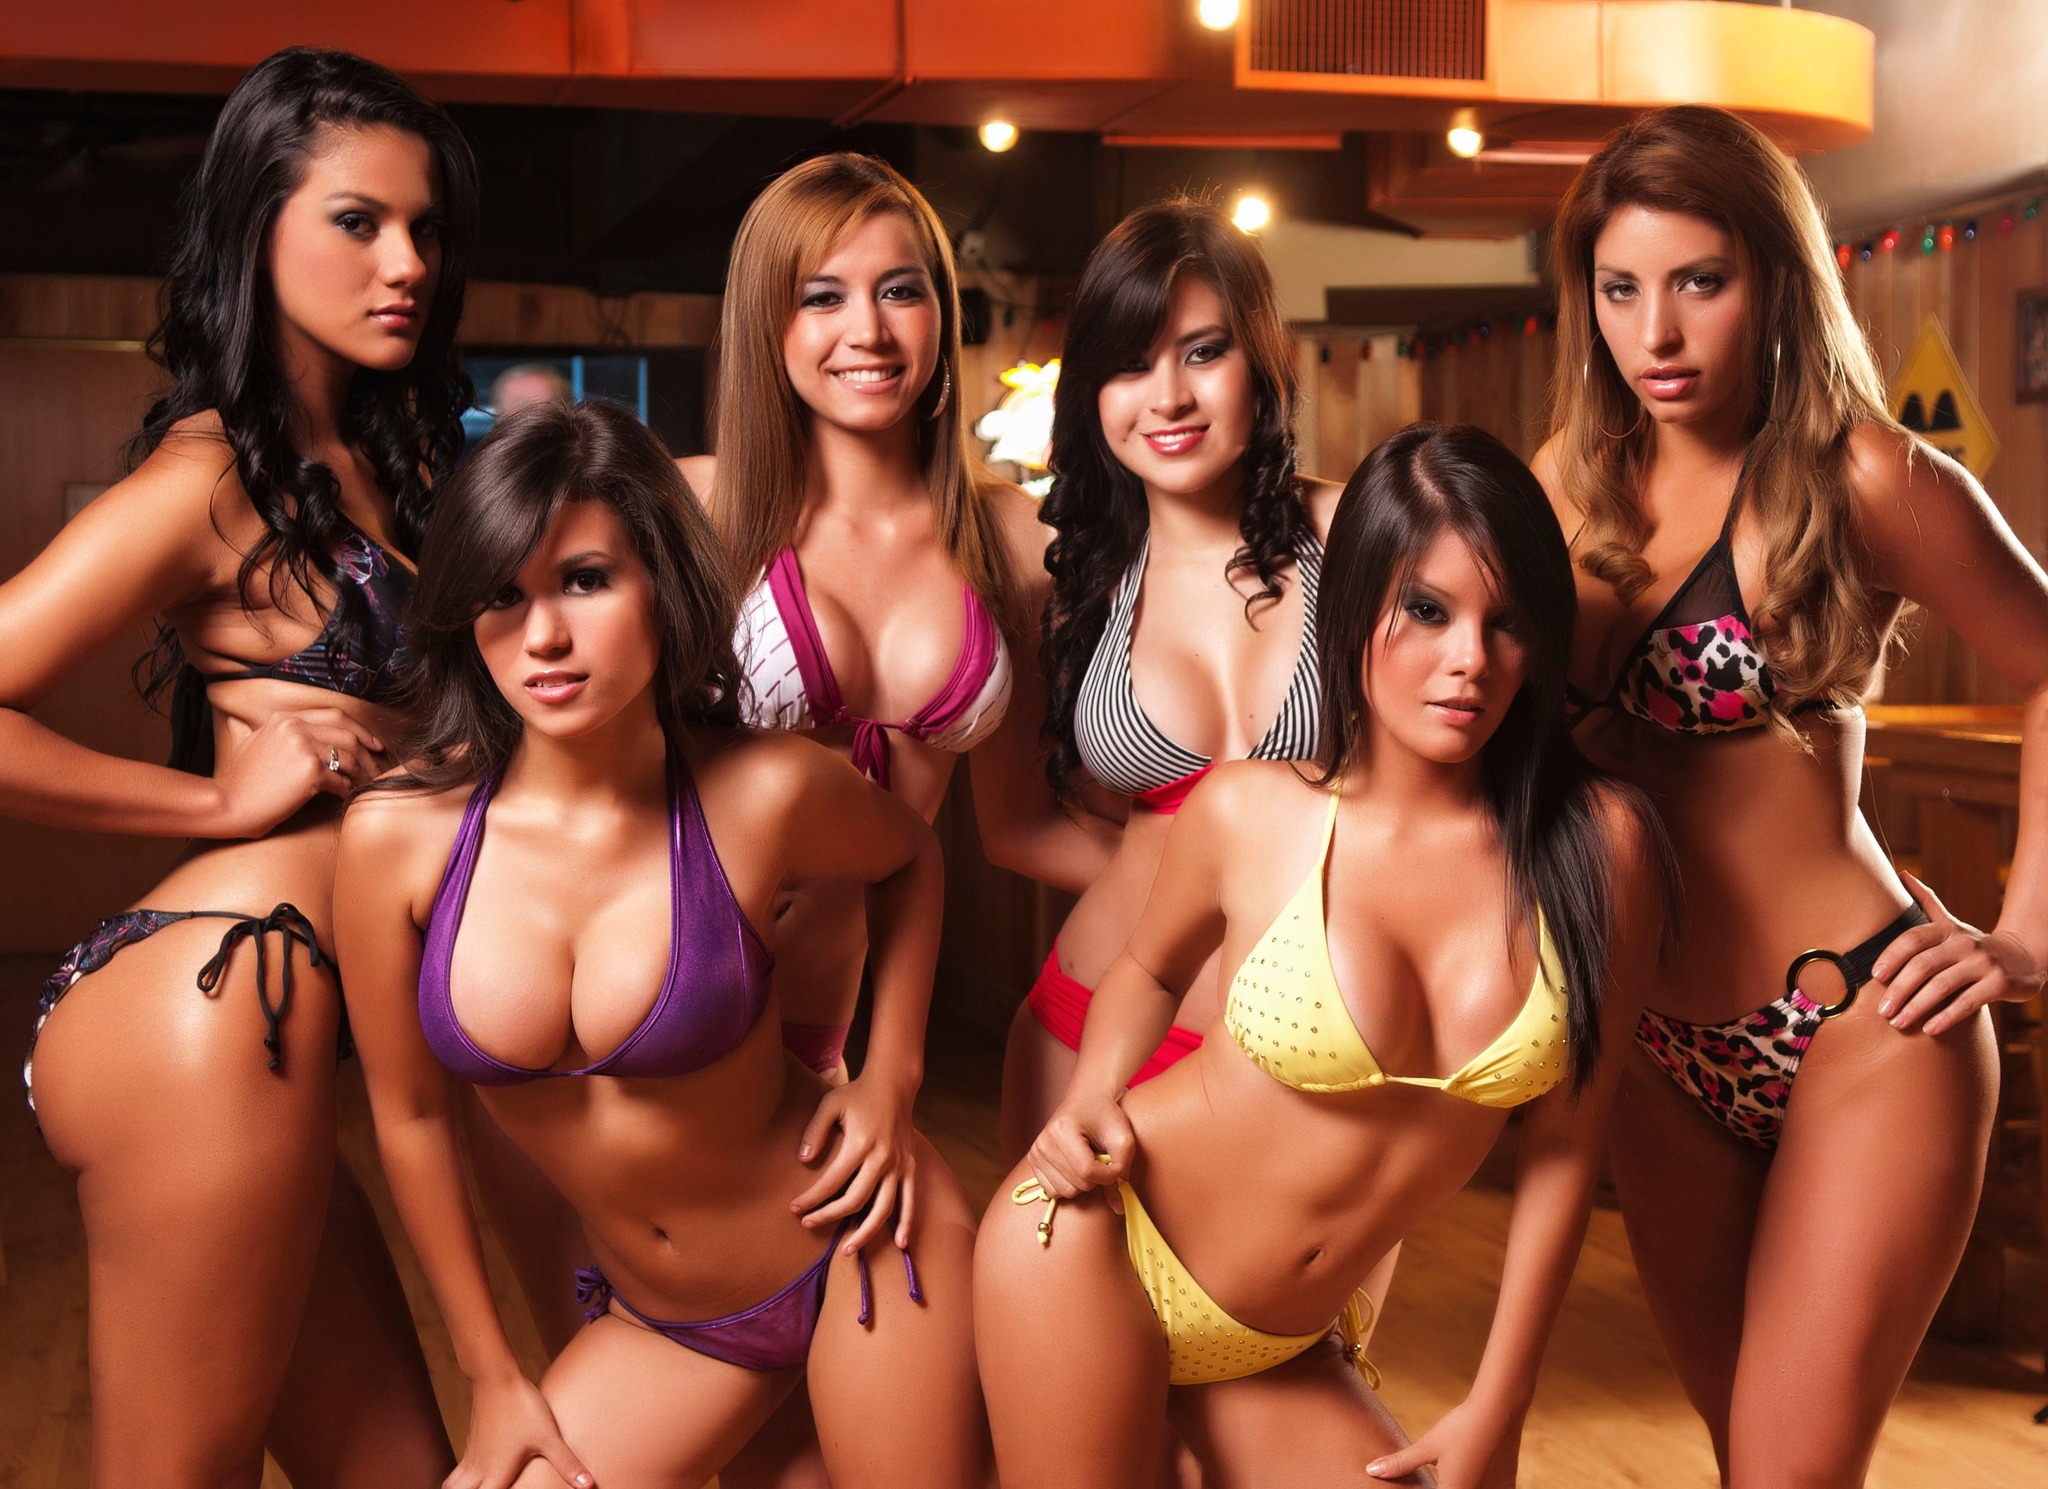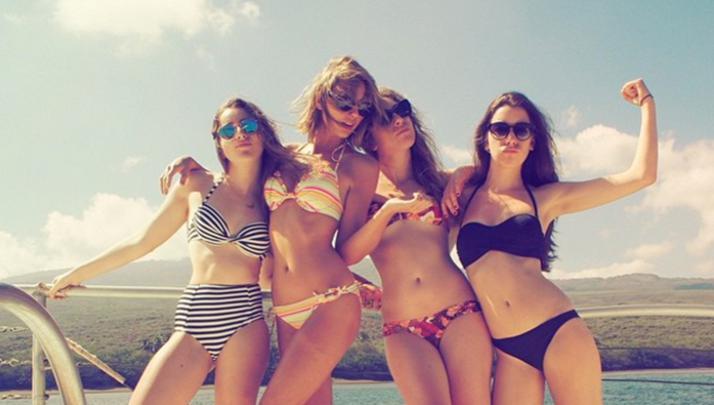The first image is the image on the left, the second image is the image on the right. Analyze the images presented: Is the assertion "There are three girls posing together in bikinis in the right image." valid? Answer yes or no. No. The first image is the image on the left, the second image is the image on the right. For the images displayed, is the sentence "The right image has three women standing outside." factually correct? Answer yes or no. No. 